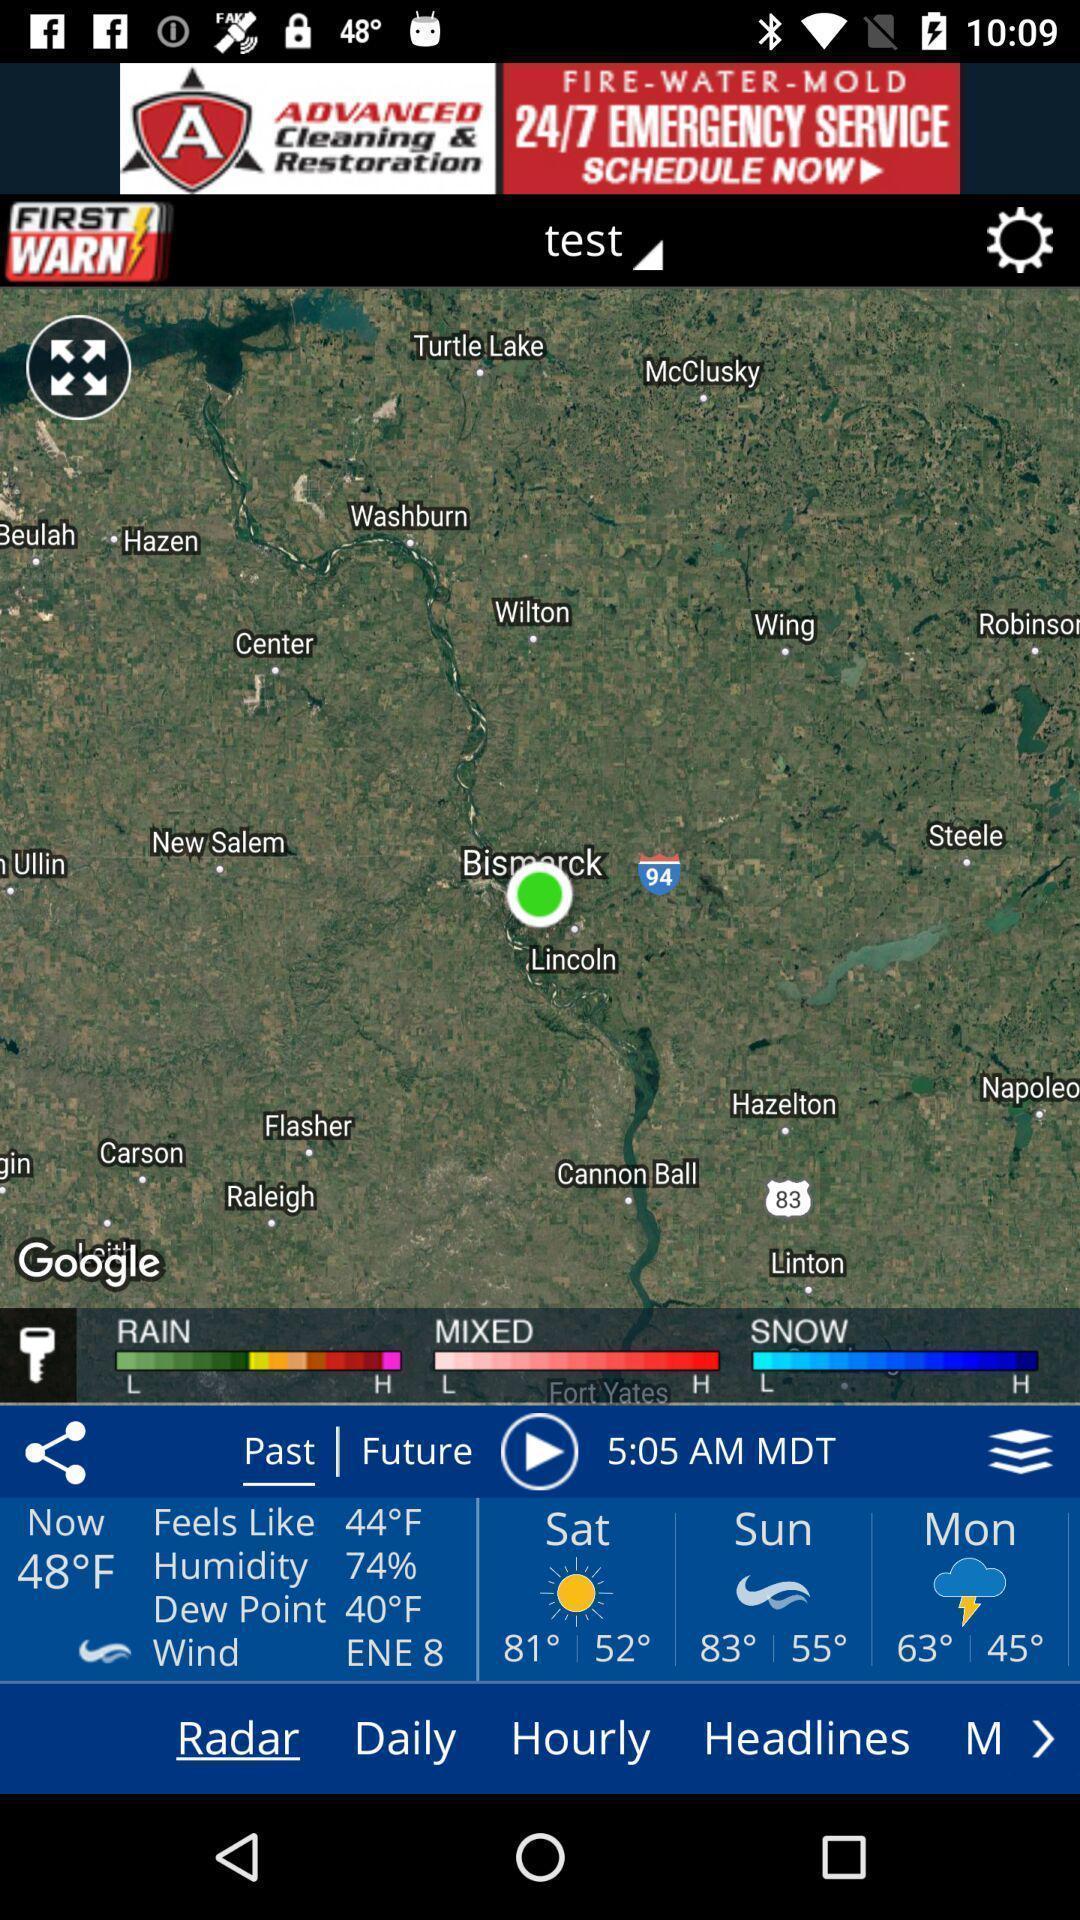What details can you identify in this image? Social app for finding weather reports. 